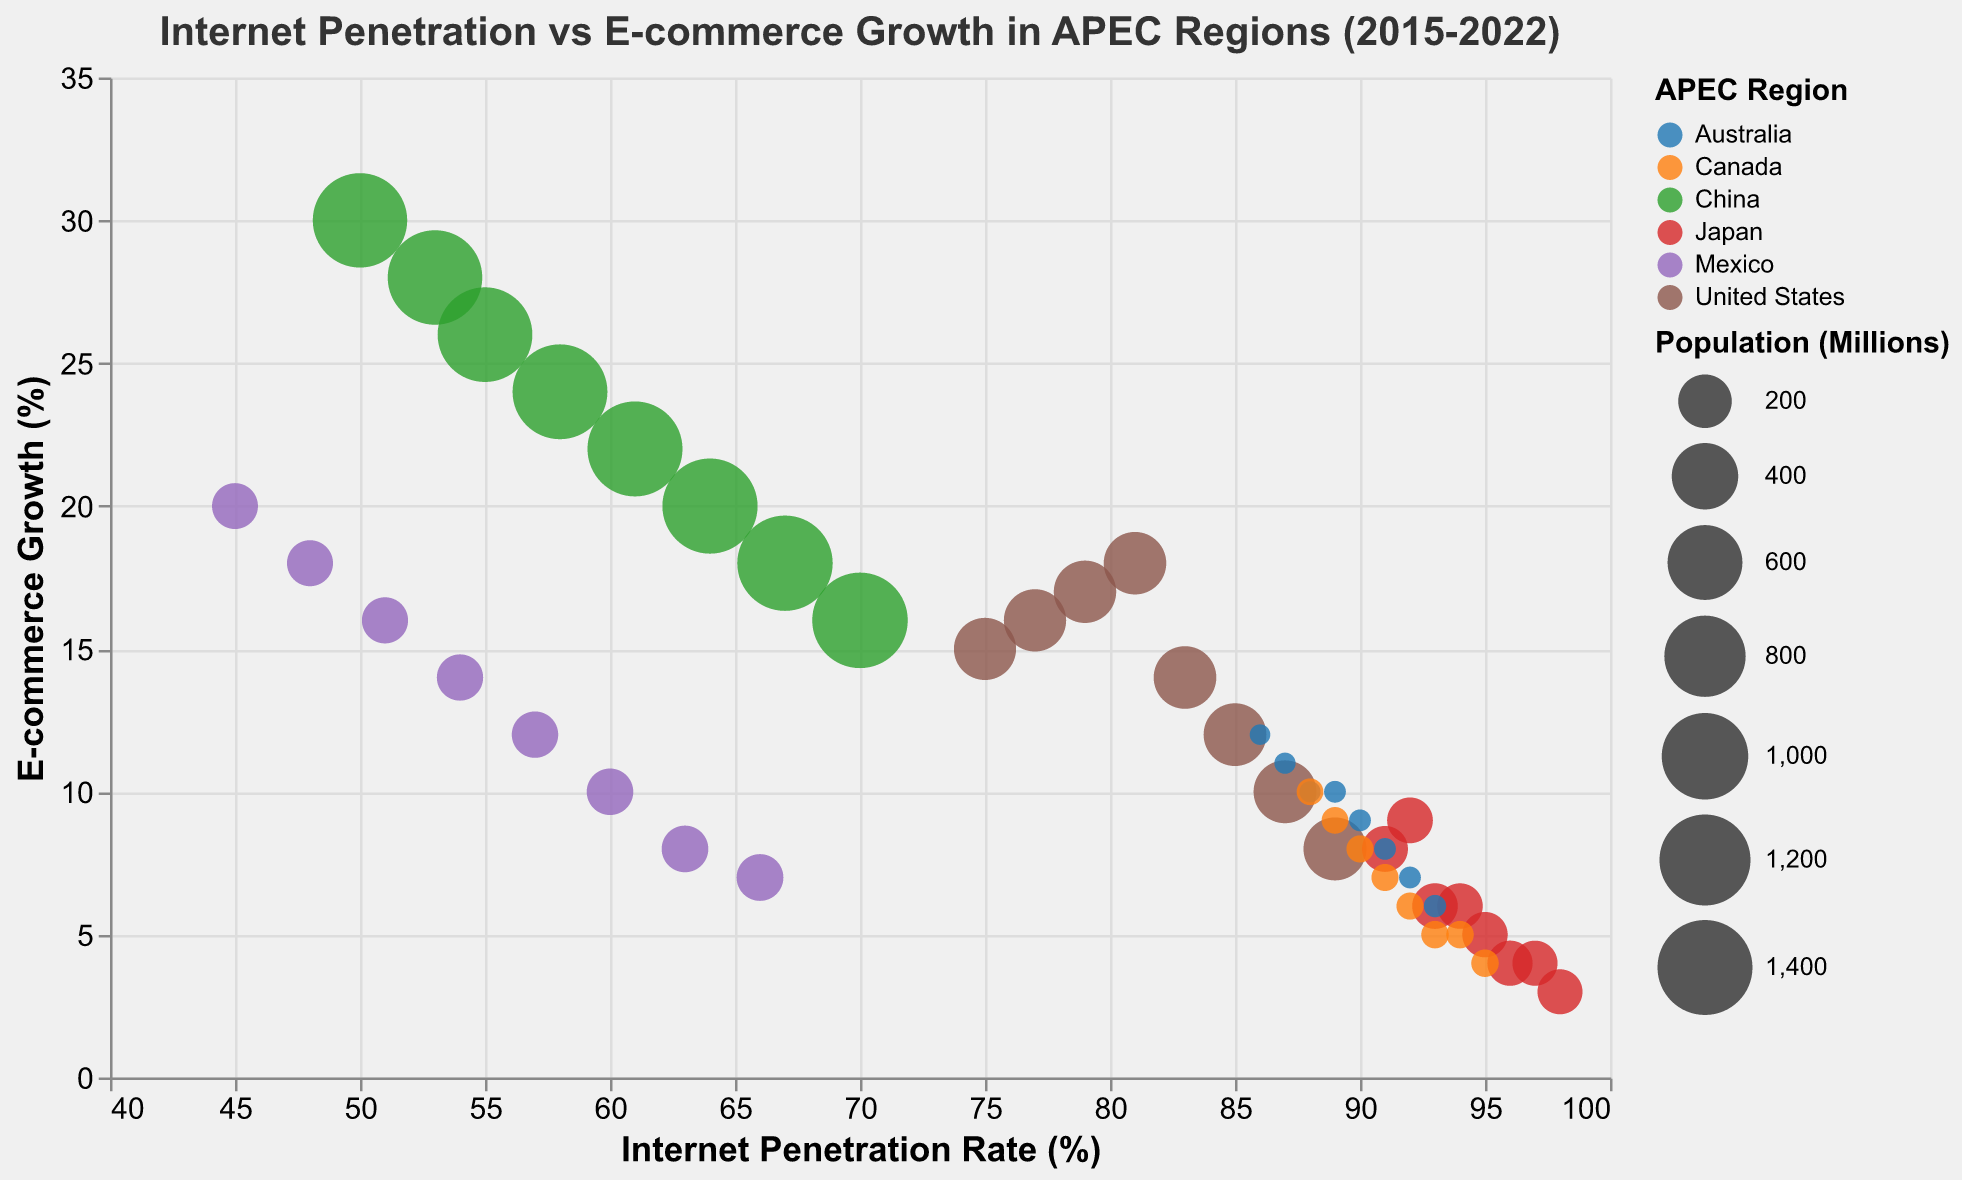What is the title of the bubble chart? The title can be found at the top of the figure. It provides a summary of what the chart represents. In this case, the title is "Internet Penetration vs E-commerce Growth in APEC Regions (2015-2022)"
Answer: Internet Penetration vs E-commerce Growth in APEC Regions (2015-2022) Which APEC region had the highest internet penetration rate in 2022? This can be determined by locating the year 2022 and finding the bubble with the highest x-axis value. The region with the highest internet penetration rate in 2022 is Japan with an internet penetration rate of 98%.
Answer: Japan What is the internet penetration rate and e-commerce growth for the United States in 2019? To find this, locate the bubble for the United States in the year 2019. The x-axis represents internet penetration rate, and the y-axis represents e-commerce growth. For the US in 2019, the internet penetration rate is 83%, and e-commerce growth is 14%.
Answer: 83% and 14% Which region shows the largest bubble size? The bubble size represents the population. By comparing the sizes of the bubbles, it is evident that China has the largest bubble size due to its high population.
Answer: China What trend in e-commerce growth can be observed for China from 2015 to 2022? Observing the bubbles for China across the years from 2015 to 2022 and looking at the y-axis, a consistent decreasing trend in e-commerce growth can be noted. E-commerce growth starts at 30% in 2015 and declines to 16% in 2022.
Answer: Decreasing trend Which APEC region experienced the largest decline in e-commerce growth from 2015 to 2022? To determine this, examine the difference in e-commerce growth from 2015 to 2022 for each region. The United States experienced a decline from 15% to 8%, which is the largest decline when compared to changes in other regions.
Answer: United States How does Japan's internet penetration rate correlate with its e-commerce growth from 2015 to 2022? By examining Japan’s data points and observing the trend, we see that as the internet penetration rate increased from 91% to 98%, the e-commerce growth rate decreased from 8% to 3%. This indicates an inverse correlation.
Answer: Inverse correlation Which two regions have similar internet penetration rates but different e-commerce growth rates around 2020? Look for regions with nearly the same x-axis values around 2020. For 2020, Japan and Australia both have internet penetration rates around 96% and 91%, respectively, but their e-commerce growth rates are 4% and 8%, respectively.
Answer: Japan and Australia Comparing Canada and Mexico in 2016, which region had a higher internet penetration rate and e-commerce growth? Locate the bubbles for Canada and Mexico in 2016. Canada had an internet penetration rate of 89% and e-commerce growth of 9%, while Mexico had 48% and 18%, respectively. Canada had a higher internet penetration rate, but Mexico had higher e-commerce growth.
Answer: Canada had a higher internet penetration, Mexico had higher e-commerce growth 